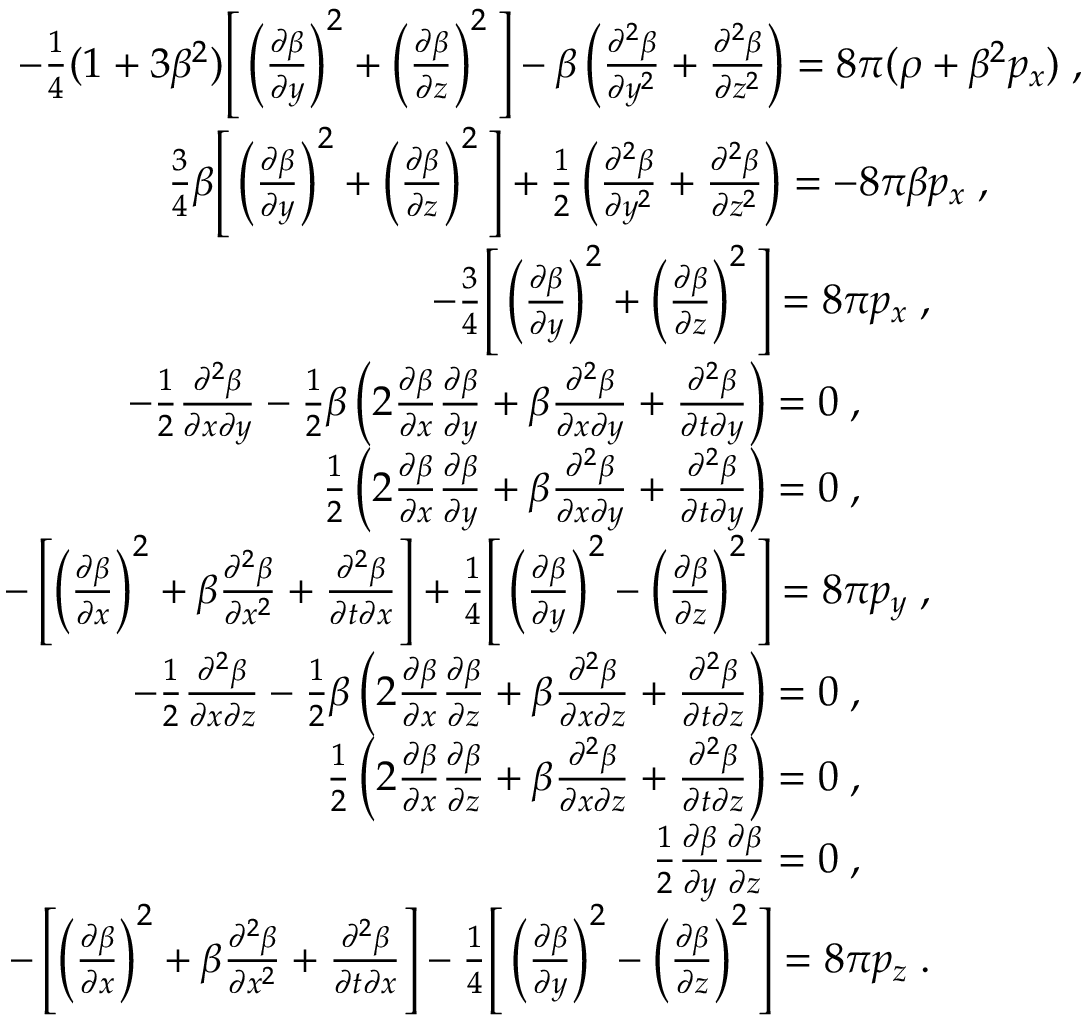<formula> <loc_0><loc_0><loc_500><loc_500>\begin{array} { r l } { - \frac { 1 } { 4 } ( 1 + 3 \beta ^ { 2 } ) \left [ \left ( \frac { \partial \beta } { \partial y } \right ) ^ { 2 } + \left ( \frac { \partial \beta } { \partial z } \right ) ^ { 2 } \right ] - \beta \left ( \frac { \partial ^ { 2 } \beta } { \partial y ^ { 2 } } + \frac { \partial ^ { 2 } \beta } { \partial z ^ { 2 } } \right ) = 8 \pi ( \rho + \beta ^ { 2 } p _ { x } ) \, , } \\ { \frac { 3 } { 4 } \beta \left [ \left ( \frac { \partial \beta } { \partial y } \right ) ^ { 2 } + \left ( \frac { \partial \beta } { \partial z } \right ) ^ { 2 } \right ] + \frac { 1 } { 2 } \left ( \frac { \partial ^ { 2 } \beta } { \partial y ^ { 2 } } + \frac { \partial ^ { 2 } \beta } { \partial z ^ { 2 } } \right ) = - 8 \pi \beta p _ { x } \, , \, } \\ { - \frac { 3 } { 4 } \left [ \left ( \frac { \partial \beta } { \partial y } \right ) ^ { 2 } + \left ( \frac { \partial \beta } { \partial z } \right ) ^ { 2 } \right ] = 8 \pi p _ { x } \, , \, } \\ { - \frac { 1 } { 2 } \frac { \partial ^ { 2 } \beta } { \partial x \partial y } - \frac { 1 } { 2 } \beta \left ( 2 \frac { \partial \beta } { \partial x } \frac { \partial \beta } { \partial y } + \beta \frac { \partial ^ { 2 } \beta } { \partial x \partial y } + \frac { \partial ^ { 2 } \beta } { \partial t \partial y } \right ) = 0 \, , \, } \\ { \frac { 1 } { 2 } \left ( 2 \frac { \partial \beta } { \partial x } \frac { \partial \beta } { \partial y } + \beta \frac { \partial ^ { 2 } \beta } { \partial x \partial y } + \frac { \partial ^ { 2 } \beta } { \partial t \partial y } \right ) = 0 \, , \, } \\ { - \left [ \left ( \frac { \partial \beta } { \partial x } \right ) ^ { 2 } + \beta \frac { \partial ^ { 2 } \beta } { \partial x ^ { 2 } } + \frac { \partial ^ { 2 } \beta } { \partial t \partial x } \right ] + \frac { 1 } { 4 } \left [ \left ( \frac { \partial \beta } { \partial y } \right ) ^ { 2 } - \left ( \frac { \partial \beta } { \partial z } \right ) ^ { 2 } \right ] = 8 \pi p _ { y } \, , \, } \\ { - \frac { 1 } { 2 } \frac { \partial ^ { 2 } \beta } { \partial x \partial z } - \frac { 1 } { 2 } \beta \left ( 2 \frac { \partial \beta } { \partial x } \frac { \partial \beta } { \partial z } + \beta \frac { \partial ^ { 2 } \beta } { \partial x \partial z } + \frac { \partial ^ { 2 } \beta } { \partial t \partial z } \right ) = 0 \, , \, } \\ { \frac { 1 } { 2 } \left ( 2 \frac { \partial \beta } { \partial x } \frac { \partial \beta } { \partial z } + \beta \frac { \partial ^ { 2 } \beta } { \partial x \partial z } + \frac { \partial ^ { 2 } \beta } { \partial t \partial z } \right ) = 0 \, , \, } \\ { \frac { 1 } { 2 } \frac { \partial \beta } { \partial y } \frac { \partial \beta } { \partial z } = 0 \, , \, } \\ { - \left [ \left ( \frac { \partial \beta } { \partial x } \right ) ^ { 2 } + \beta \frac { \partial ^ { 2 } \beta } { \partial x ^ { 2 } } + \frac { \partial ^ { 2 } \beta } { \partial t \partial x } \right ] - \frac { 1 } { 4 } \left [ \left ( \frac { \partial \beta } { \partial y } \right ) ^ { 2 } - \left ( \frac { \partial \beta } { \partial z } \right ) ^ { 2 } \right ] = 8 \pi p _ { z } \, . \, } \end{array}</formula> 